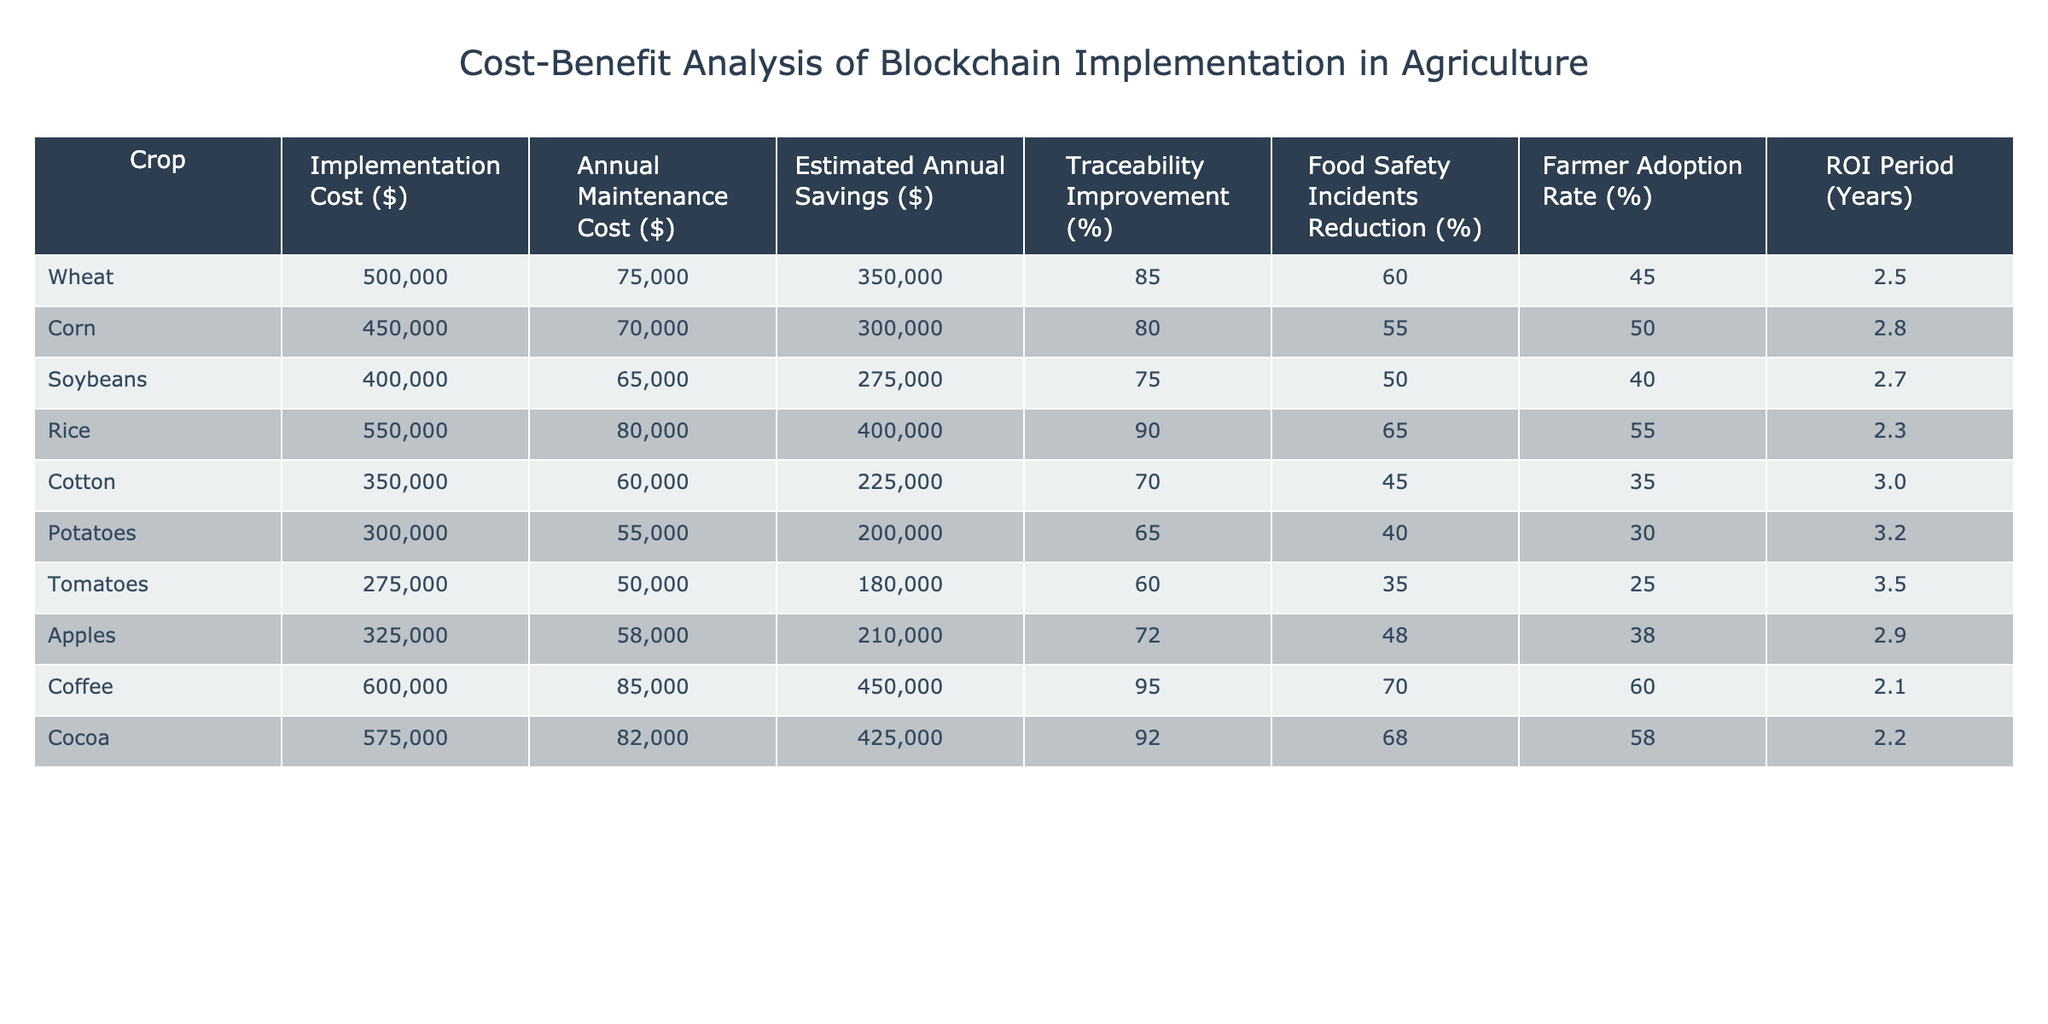What is the implementation cost for corn? The table shows that the implementation cost for corn is $450,000, which is clearly listed under the "Implementation Cost ($)" column.
Answer: $450,000 Which crop has the highest traceability improvement percentage? By reviewing the traceability improvement percentages in the table, rice has the highest percentage at 90%.
Answer: 90% What is the average annual maintenance cost across all crops? To find the average annual maintenance cost, we sum the maintenance costs: (75,000 + 70,000 + 65,000 + 80,000 + 60,000 + 55,000 + 50,000 + 58,000 + 85,000 + 82,000) =  755,000. There are 10 crops, so the average is 755,000 / 10 = 75,500.
Answer: $75,500 Is the ROI period for coffee less than the average ROI period for all crops listed? First, we need to calculate the average ROI period of all crops: (2.5 + 2.8 + 2.7 + 2.3 + 3.0 + 3.2 + 3.5 + 2.9 + 2.1 + 2.2) / 10 = 2.57. Coffee's ROI period is 2.1, which is less than 2.57.
Answer: Yes What is the difference in estimated annual savings between wheat and potatoes? The estimated annual savings for wheat is $350,000 and for potatoes is $200,000. The difference is $350,000 - $200,000 = $150,000.
Answer: $150,000 Which crop has the lowest maintenance cost and what is that amount? Looking at the maintenance costs, tomatoes have the lowest at $50,000 as indicated in the "Annual Maintenance Cost ($)" column.
Answer: $50,000 How many crops have a farmer adoption rate higher than 50%? By examining the farmer adoption rates in the table, corn (50%), rice (55%), apples (38%), and coffee (60%) exceed 50%, totaling to 4 crops.
Answer: 4 crops What is the highest estimated annual savings and which crop achieves this? The estimated annual savings are $450,000 for coffee, which is the highest value listed in that column.
Answer: $450,000 (Coffee) What is the average traceability improvement percentage for the crops listed? The traceability improvement percentages are: 85, 80, 75, 90, 70, 65, 60, 72, 95, 92. Adding these values gives  85 + 80 + 75 + 90 + 70 + 65 + 60 + 72 + 95 + 92 =  819. Dividing by 10 gives an average of 81.9%.
Answer: 81.9% Is the food safety incidents reduction percentage for soybeans equal to the food safety incidents reduction percentage for cotton? The table shows soybeans with 50% reduction and cotton with 45%, which are not equal.
Answer: No 